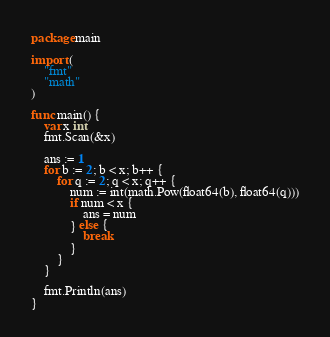Convert code to text. <code><loc_0><loc_0><loc_500><loc_500><_Go_>package main

import (
	"fmt"
	"math"
)

func main() {
	var x int
	fmt.Scan(&x)

	ans := 1
	for b := 2; b < x; b++ {
		for q := 2; q < x; q++ {
			num := int(math.Pow(float64(b), float64(q)))
			if num < x {
				ans = num
			} else {
				break
			}
		}
	}

	fmt.Println(ans)
}
</code> 